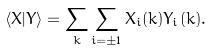<formula> <loc_0><loc_0><loc_500><loc_500>\langle X | Y \rangle = \sum _ { k } \sum _ { i = \pm 1 } X _ { i } ( k ) Y _ { i } ( k ) .</formula> 